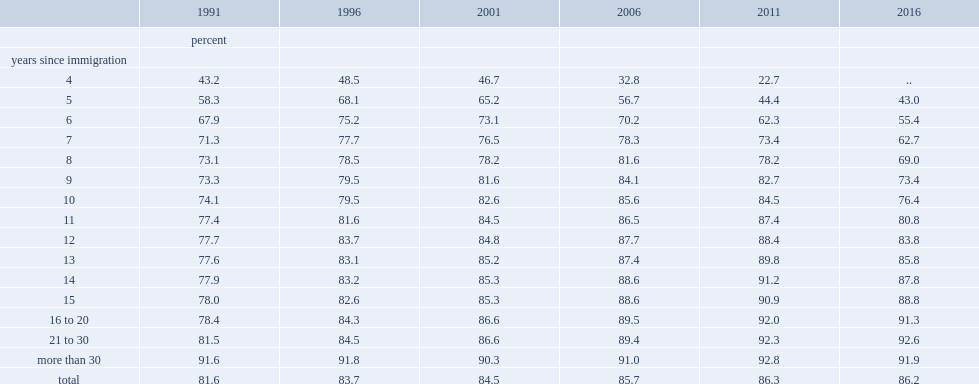Among immigrants who had lived in canada for 21 to 30 years, what was the citizenship rate in 1991? 81.5. Among immigrants who had lived in canada for 21 to 30 years, what was the citizenship rate in 2016? 92.6. Among immigrants in canada for five years, what was the citizenship rate in 1996? 68.1. Among immigrants in canada for five years, what was the citizenship rate in 2016? 43. Among immigrants in canada for nine years, what was the citizenship rate in 2006? 84.1. Among immigrants in canada for nine years, what was the citizenship rate in 2006? 73.4. 